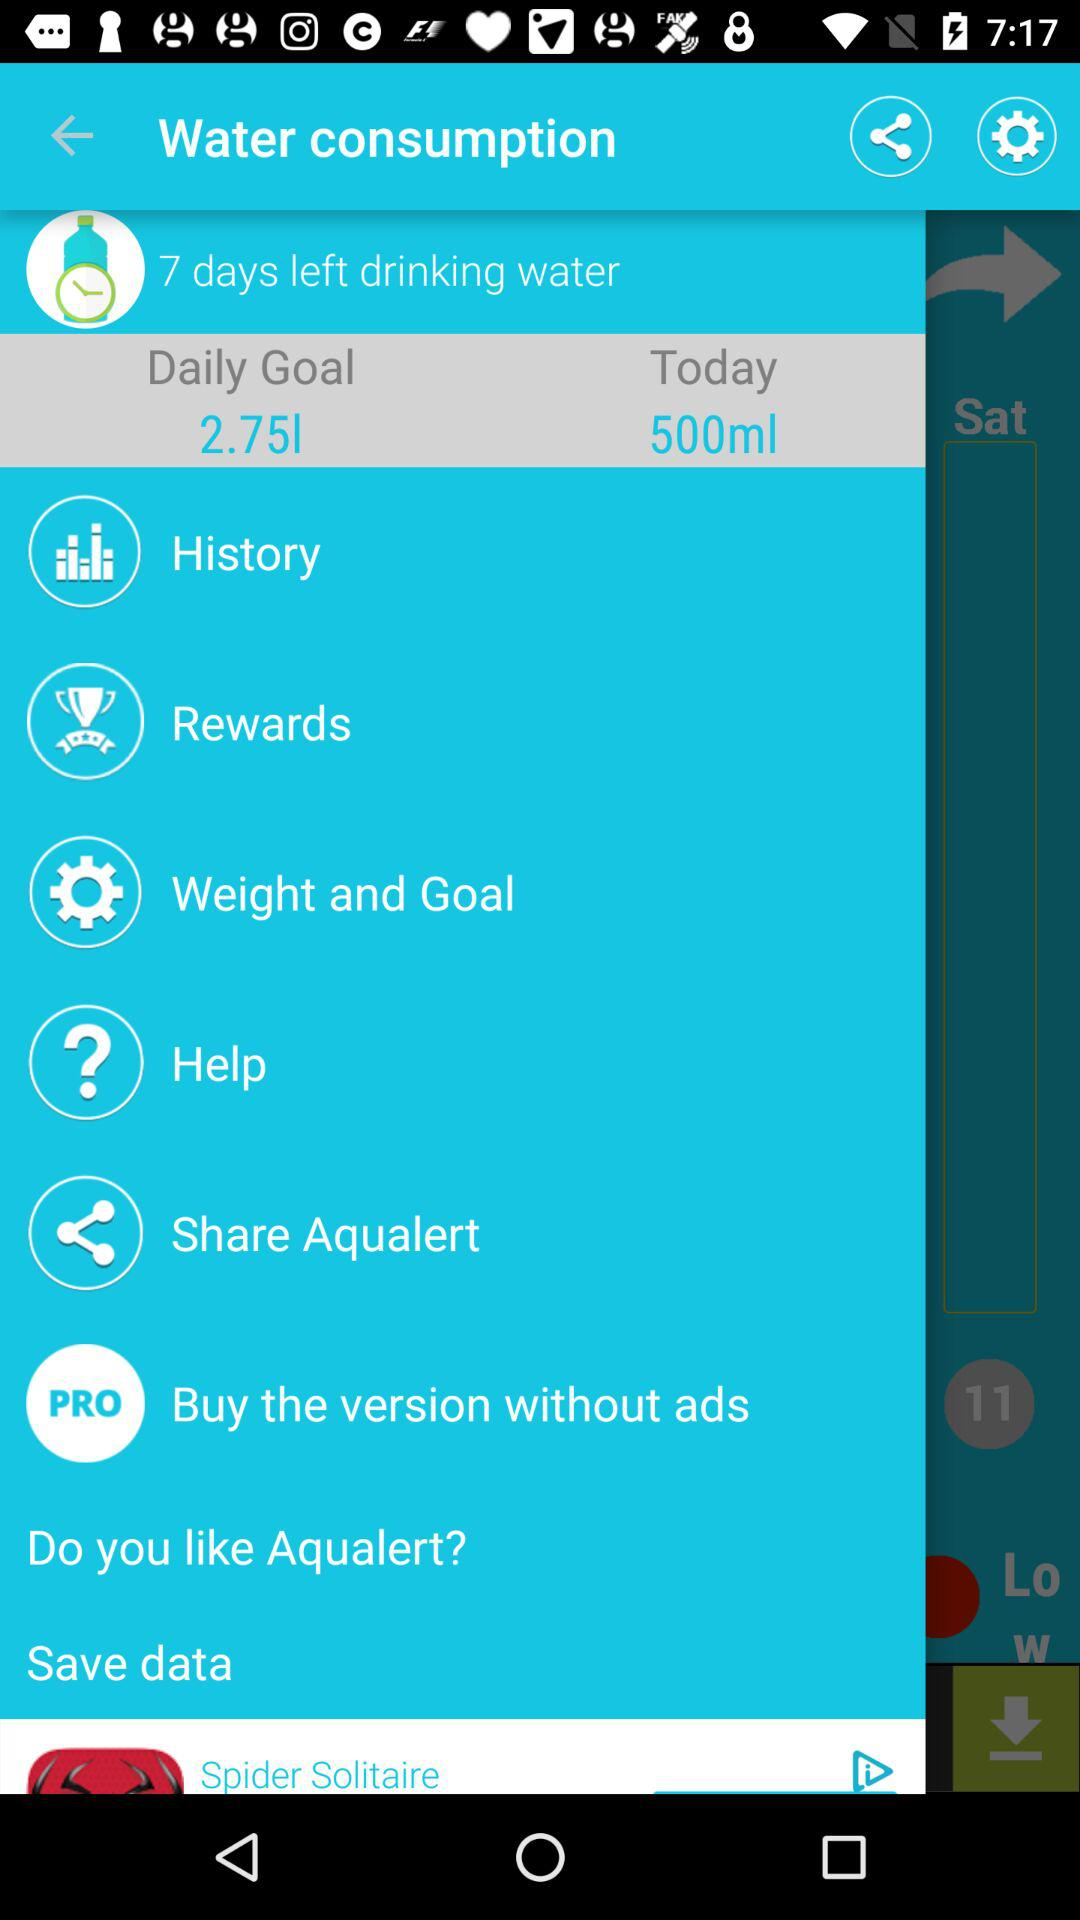With which applications can I share "Aqualert"?
When the provided information is insufficient, respond with <no answer>. <no answer> 